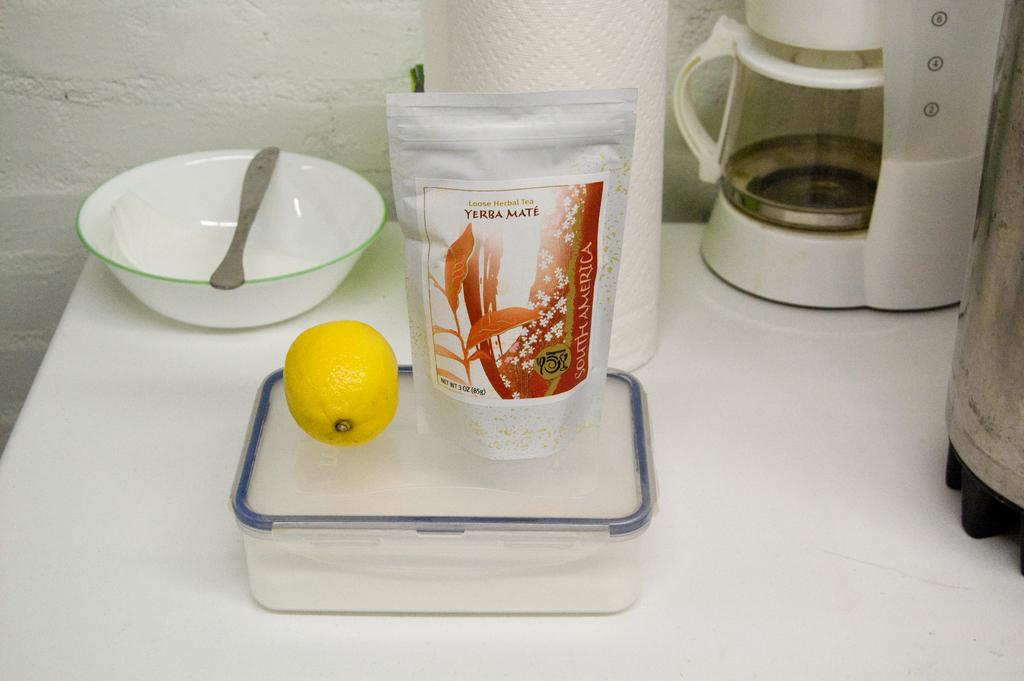What type of furniture is present in the image? There is a table in the image. What else can be seen in the background of the image? There is a wall in the image. What items are on the table in the image? There is a box, a bowl, a tissue paper roll, fruit, and a packet on the table. Are there any other objects on the table? Yes, there are other objects on the table. How many beds are visible in the image? There are no beds present in the image. What type of rod is used to hold the tramp in the image? There is no tramp or rod present in the image. 